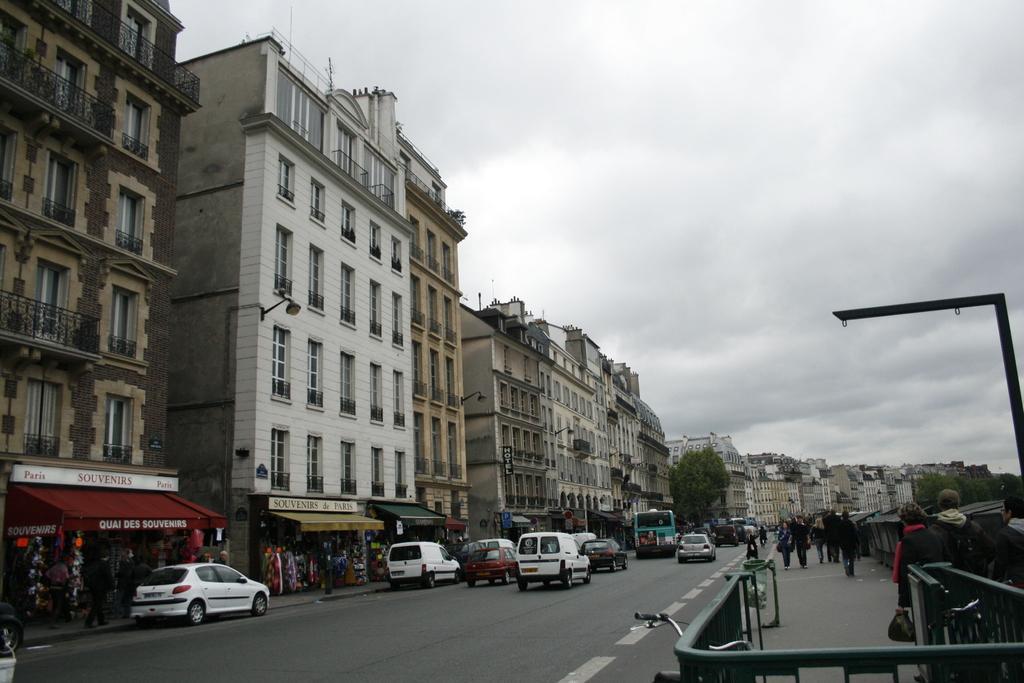Could you give a brief overview of what you see in this image? There are few buildings,stores and vehicles in the left corner and there are few people standing in the right corner and the sky is cloudy. 